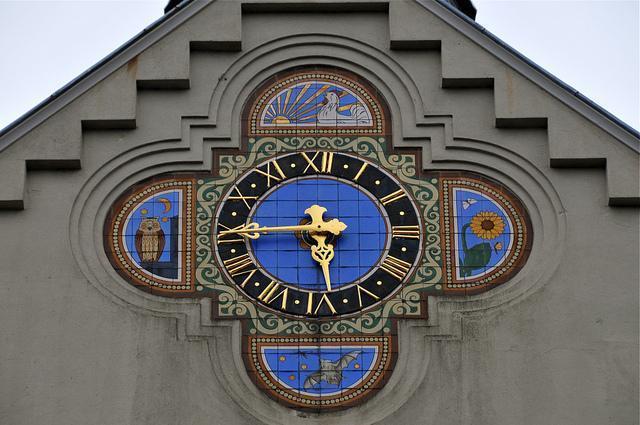How many people are in the picture?
Give a very brief answer. 0. 